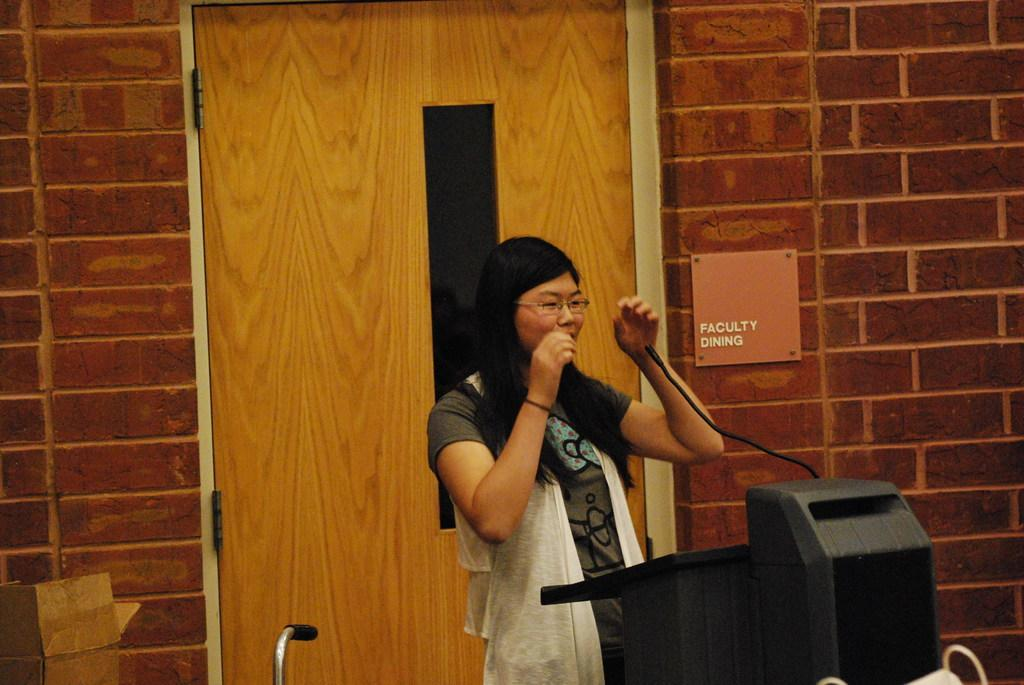Who is present in the image? There is a woman in the image. What is the woman doing in the image? The woman is standing in the image. What accessory is the woman wearing? The woman is wearing glasses (specs) in the image. What object can be seen near the woman? There is a black color microphone in the image. What type of door can be seen in the background of the image? There is a wooden door visible in the background of the image. What material is the wall visible in the background of the image made of? There is a brick wall visible in the background of the image. How many sacks of potatoes are visible in the image? There are no sacks of potatoes present in the image. What type of spacecraft can be seen in the image? There is no spacecraft present in the image. 